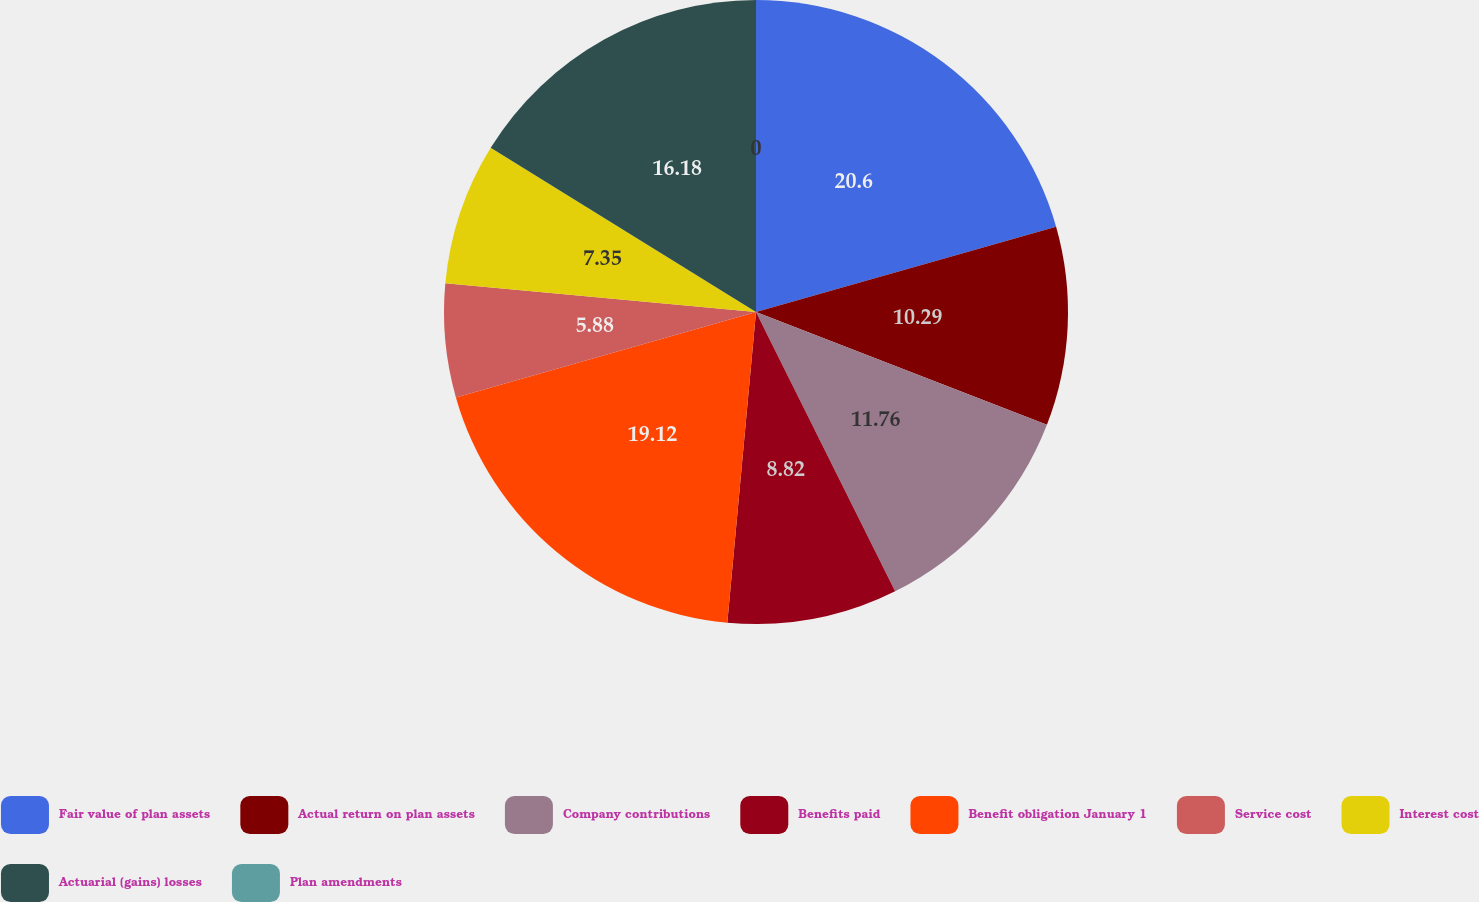<chart> <loc_0><loc_0><loc_500><loc_500><pie_chart><fcel>Fair value of plan assets<fcel>Actual return on plan assets<fcel>Company contributions<fcel>Benefits paid<fcel>Benefit obligation January 1<fcel>Service cost<fcel>Interest cost<fcel>Actuarial (gains) losses<fcel>Plan amendments<nl><fcel>20.59%<fcel>10.29%<fcel>11.76%<fcel>8.82%<fcel>19.12%<fcel>5.88%<fcel>7.35%<fcel>16.18%<fcel>0.0%<nl></chart> 